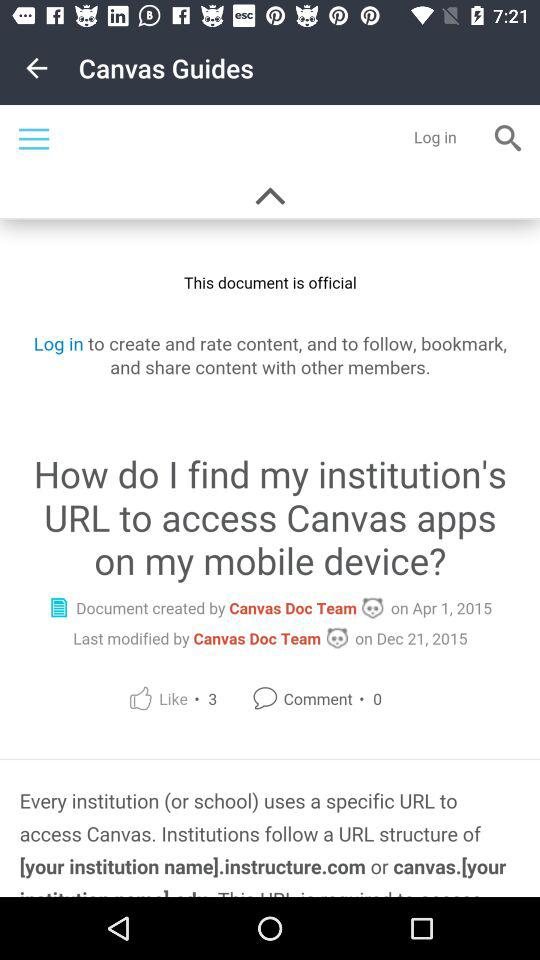On what date was the document created by the "Canvas Doc Team"? The document by the "Canvas Doc Team" was created on April 1, 2015. 